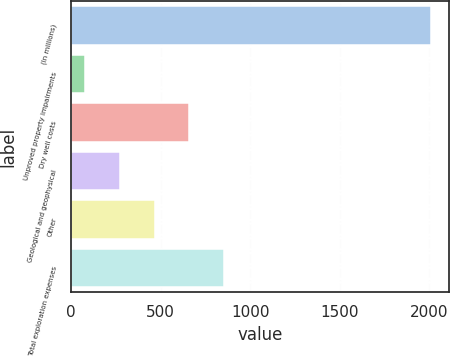Convert chart. <chart><loc_0><loc_0><loc_500><loc_500><bar_chart><fcel>(In millions)<fcel>Unproved property impairments<fcel>Dry well costs<fcel>Geological and geophysical<fcel>Other<fcel>Total exploration expenses<nl><fcel>2011<fcel>79<fcel>658.6<fcel>272.2<fcel>465.4<fcel>851.8<nl></chart> 